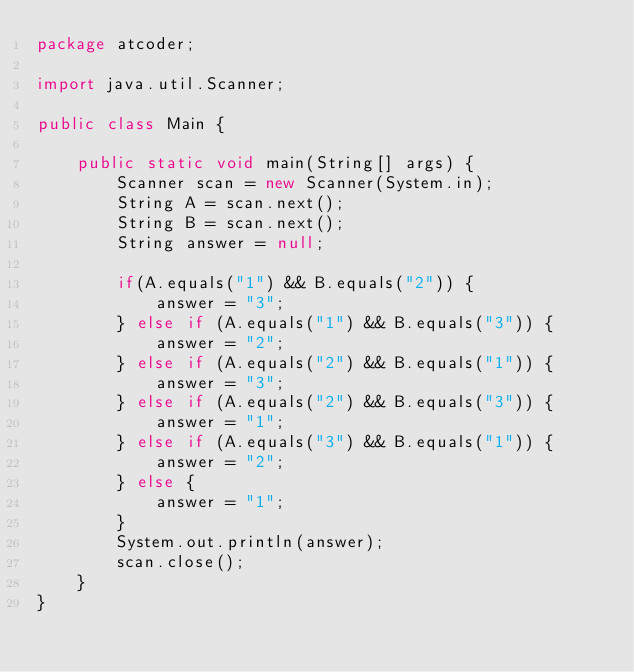<code> <loc_0><loc_0><loc_500><loc_500><_Java_>package atcoder;

import java.util.Scanner;

public class Main {

	public static void main(String[] args) {
		Scanner scan = new Scanner(System.in);
		String A = scan.next();
		String B = scan.next();
		String answer = null;

		if(A.equals("1") && B.equals("2")) {
			answer = "3";
		} else if (A.equals("1") && B.equals("3")) {
			answer = "2";
		} else if (A.equals("2") && B.equals("1")) {
			answer = "3";
		} else if (A.equals("2") && B.equals("3")) {
			answer = "1";
		} else if (A.equals("3") && B.equals("1")) {
			answer = "2";
		} else {
			answer = "1";
		}
		System.out.println(answer);
		scan.close();
	}
}
</code> 